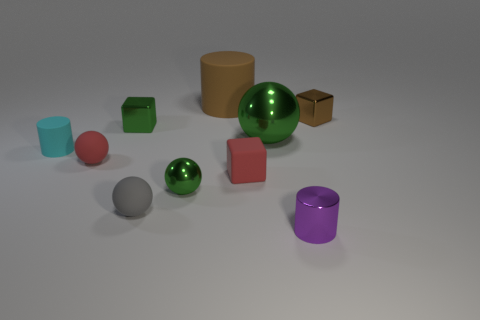How many other shiny objects are the same shape as the large brown object?
Offer a very short reply. 1. There is a small thing that is right of the tiny cylinder that is right of the green thing in front of the large green shiny object; what shape is it?
Your response must be concise. Cube. What is the material of the cylinder that is both in front of the tiny brown metal block and on the right side of the small red sphere?
Make the answer very short. Metal. Does the rubber thing that is behind the cyan rubber cylinder have the same size as the purple cylinder?
Offer a terse response. No. Is there any other thing that is the same size as the cyan matte cylinder?
Make the answer very short. Yes. Is the number of small things that are behind the purple metallic cylinder greater than the number of red rubber spheres in front of the rubber cube?
Provide a short and direct response. Yes. The matte sphere that is in front of the red matte object on the left side of the large matte object that is to the right of the cyan matte cylinder is what color?
Give a very brief answer. Gray. There is a big thing behind the tiny brown metallic block; does it have the same color as the small metal ball?
Ensure brevity in your answer.  No. How many other things are the same color as the big sphere?
Offer a very short reply. 2. How many things are big red metal blocks or tiny brown things?
Ensure brevity in your answer.  1. 